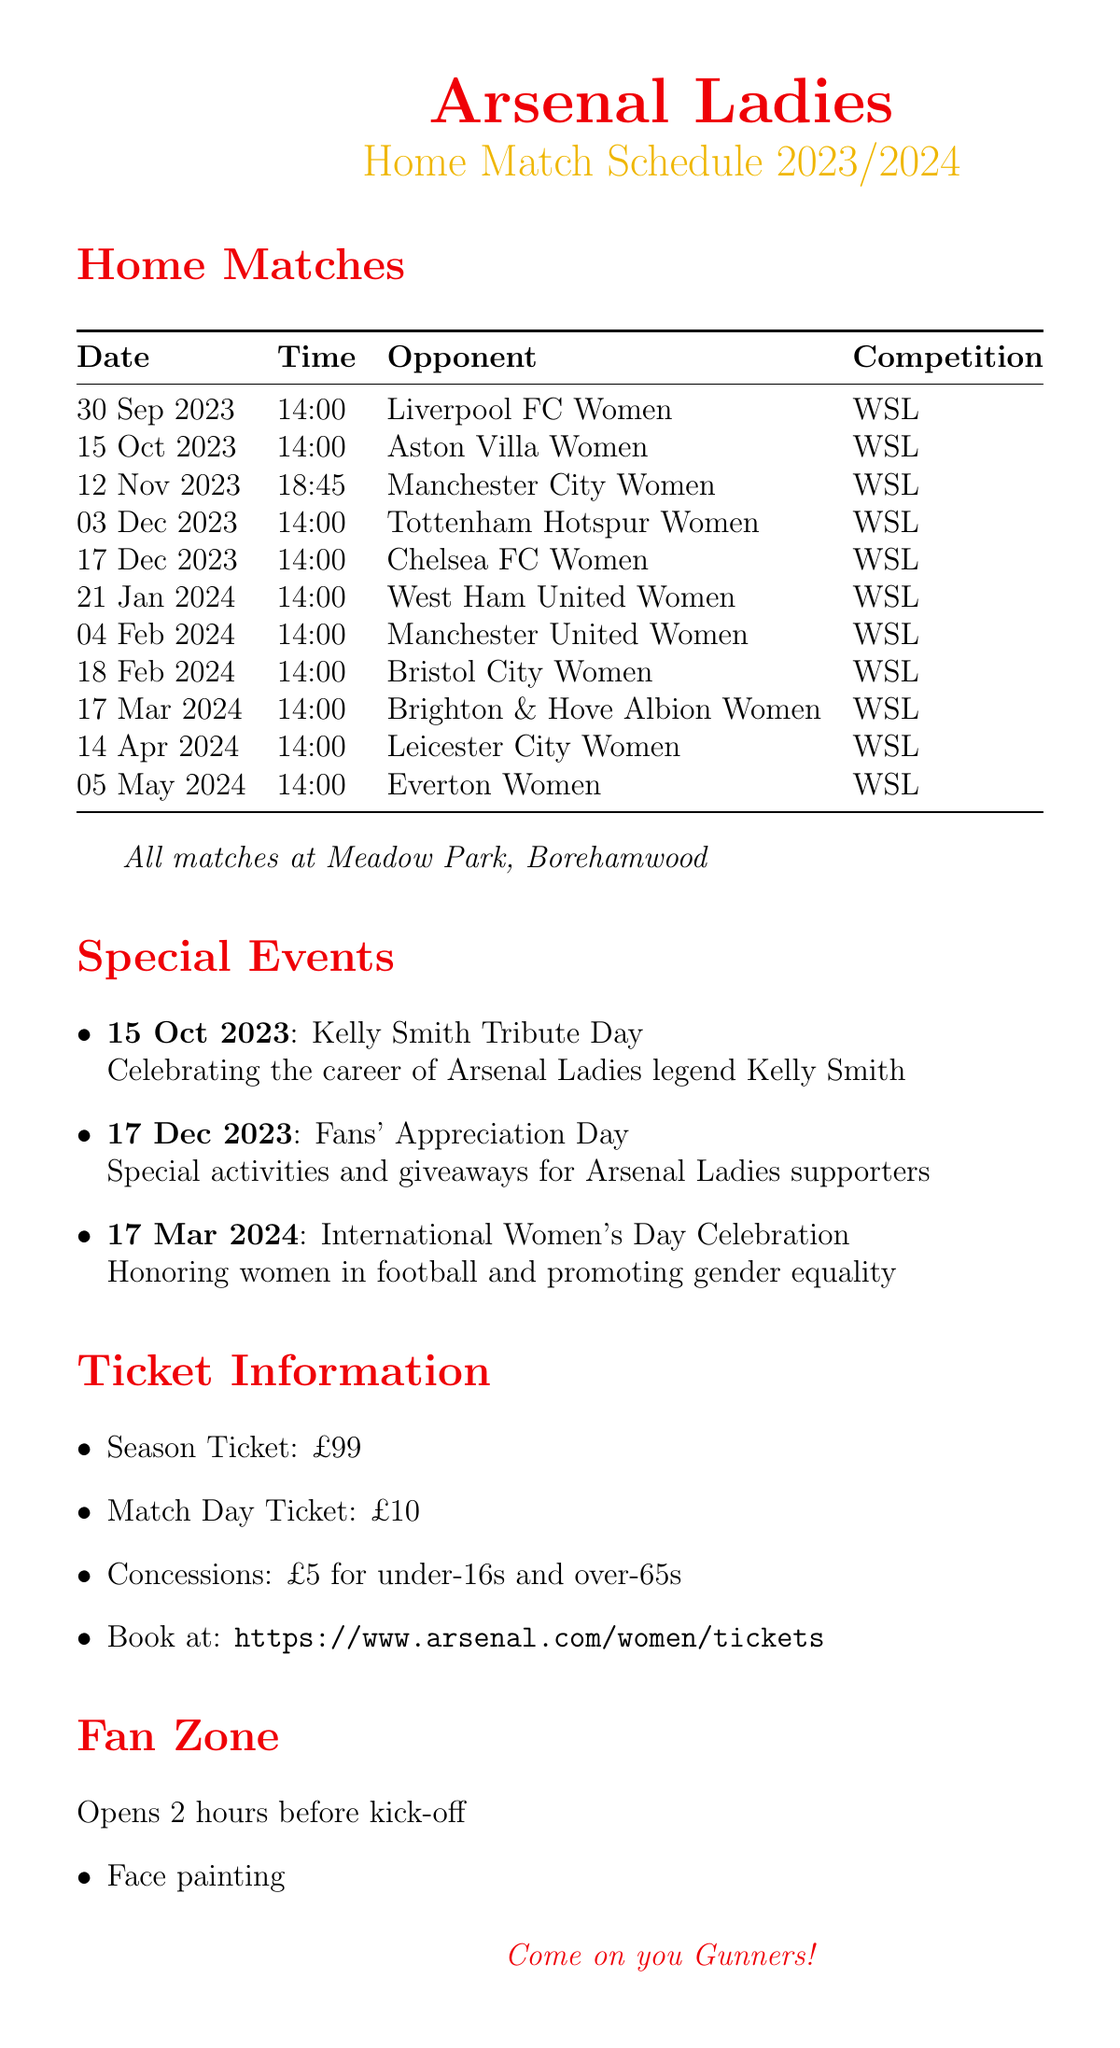What date is the first home match? The first home match is on the schedule for September 30, 2023.
Answer: September 30, 2023 What time is the match against Chelsea FC Women? The match against Chelsea FC Women is scheduled to start at 14:00.
Answer: 14:00 Who are the opponents on December 3, 2023? The opponents on December 3, 2023, are Tottenham Hotspur Women.
Answer: Tottenham Hotspur Women What special event is happening on October 15, 2023? The special event on October 15, 2023, is Kelly Smith Tribute Day, celebrating her career.
Answer: Kelly Smith Tribute Day How much is a match day ticket? The price for a match day ticket is specified in the document, which is £10.
Answer: £10 What is the venue for Arsenal Ladies home matches? The venue for the home matches is given as Meadow Park, Borehamwood.
Answer: Meadow Park, Borehamwood How many home matches are listed in the schedule? The schedule lists a total of 11 home matches for the season.
Answer: 11 What is the concession price for under-16s? The concession price for under-16s is mentioned as £5.
Answer: £5 What activities are included in the Fan Zone? The Fan Zone includes face painting, football skills challenges, meet and greet with legends, and photo opportunities with trophies.
Answer: Face painting, football skills challenges, meet and greet with legends, photo opportunities with trophies When is the International Women's Day Celebration? The International Women's Day Celebration is scheduled for March 17, 2024.
Answer: March 17, 2024 